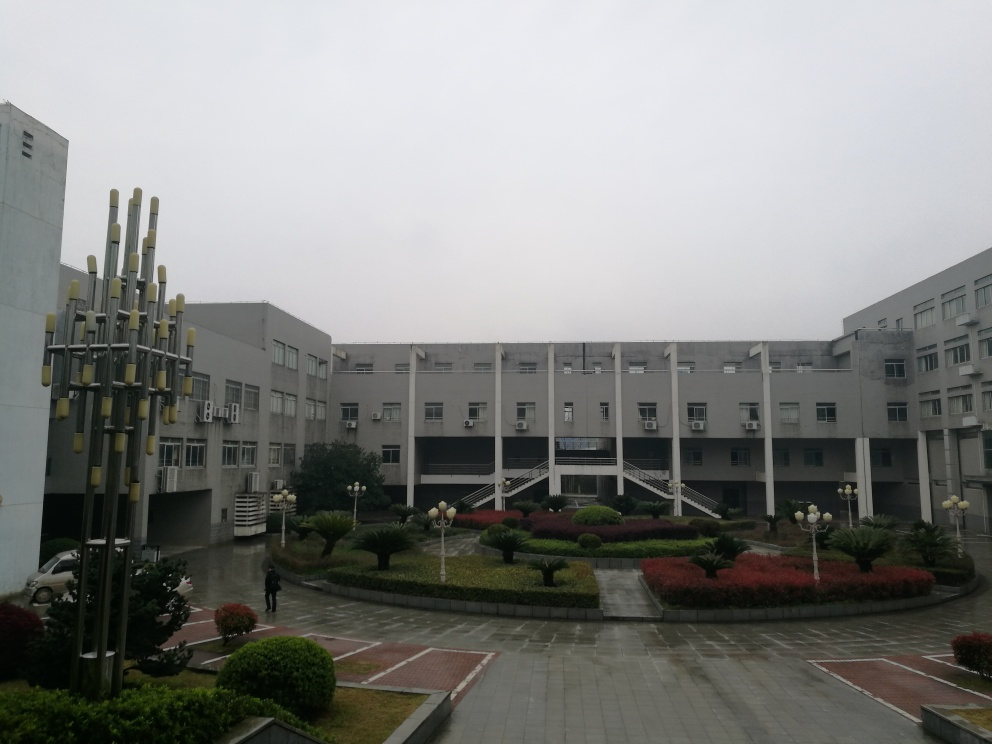What architectural style is reflected in the building design? The architectural style of the building seems modern and utilitarian. The structure features minimalist design elements with a functional aspect to it, simple lines and a lack of ornamentation contributing to a contemporary aesthetic. 